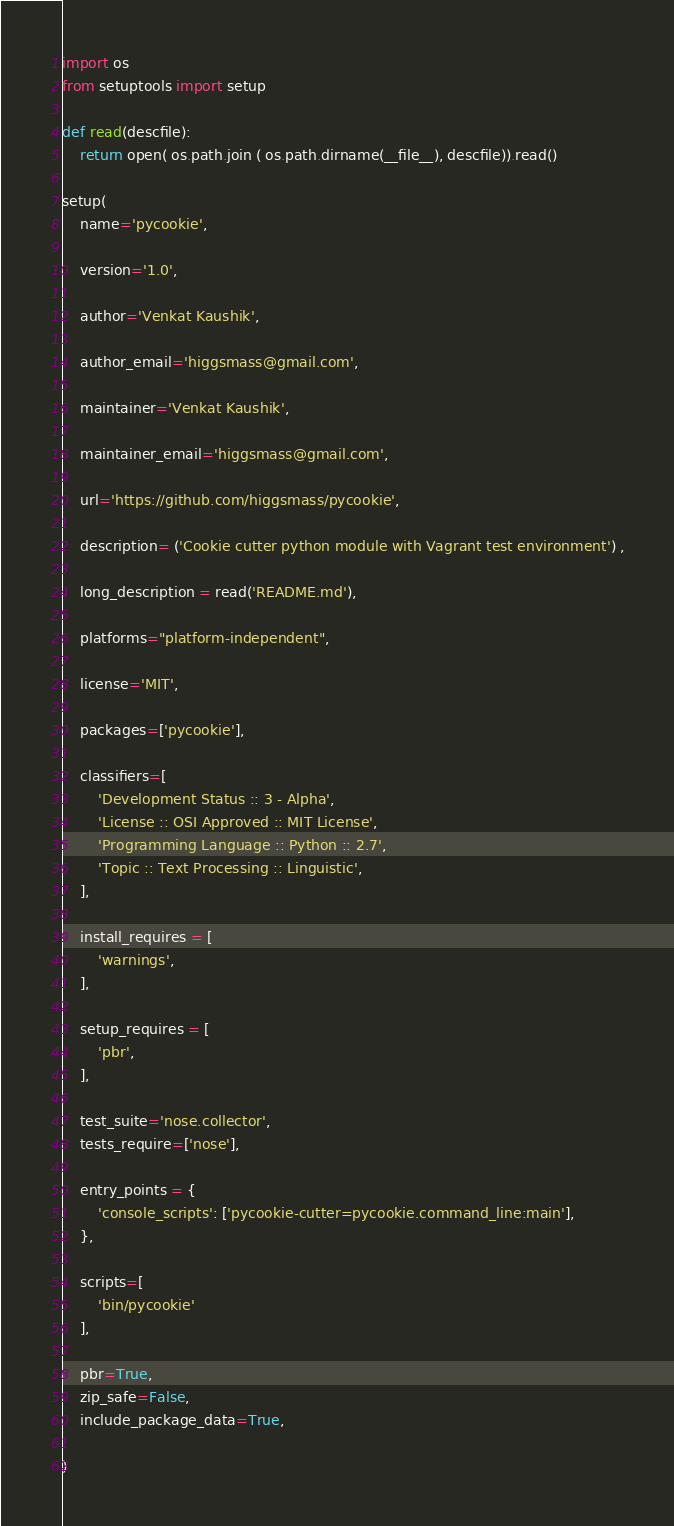<code> <loc_0><loc_0><loc_500><loc_500><_Python_>import os
from setuptools import setup

def read(descfile):
    return open( os.path.join ( os.path.dirname(__file__), descfile)).read()

setup(
    name='pycookie',

    version='1.0',

    author='Venkat Kaushik',

    author_email='higgsmass@gmail.com',

    maintainer='Venkat Kaushik',

    maintainer_email='higgsmass@gmail.com',

    url='https://github.com/higgsmass/pycookie',

    description= ('Cookie cutter python module with Vagrant test environment') ,

    long_description = read('README.md'),

    platforms="platform-independent",

    license='MIT',

    packages=['pycookie'],

    classifiers=[
        'Development Status :: 3 - Alpha',
        'License :: OSI Approved :: MIT License',
        'Programming Language :: Python :: 2.7',
        'Topic :: Text Processing :: Linguistic',
    ],

    install_requires = [
        'warnings',
    ],

    setup_requires = [
        'pbr',
    ],

    test_suite='nose.collector',
    tests_require=['nose'],

    entry_points = {
        'console_scripts': ['pycookie-cutter=pycookie.command_line:main'],
    },

    scripts=[
        'bin/pycookie'
    ],

    pbr=True,
    zip_safe=False,
    include_package_data=True,

)
</code> 